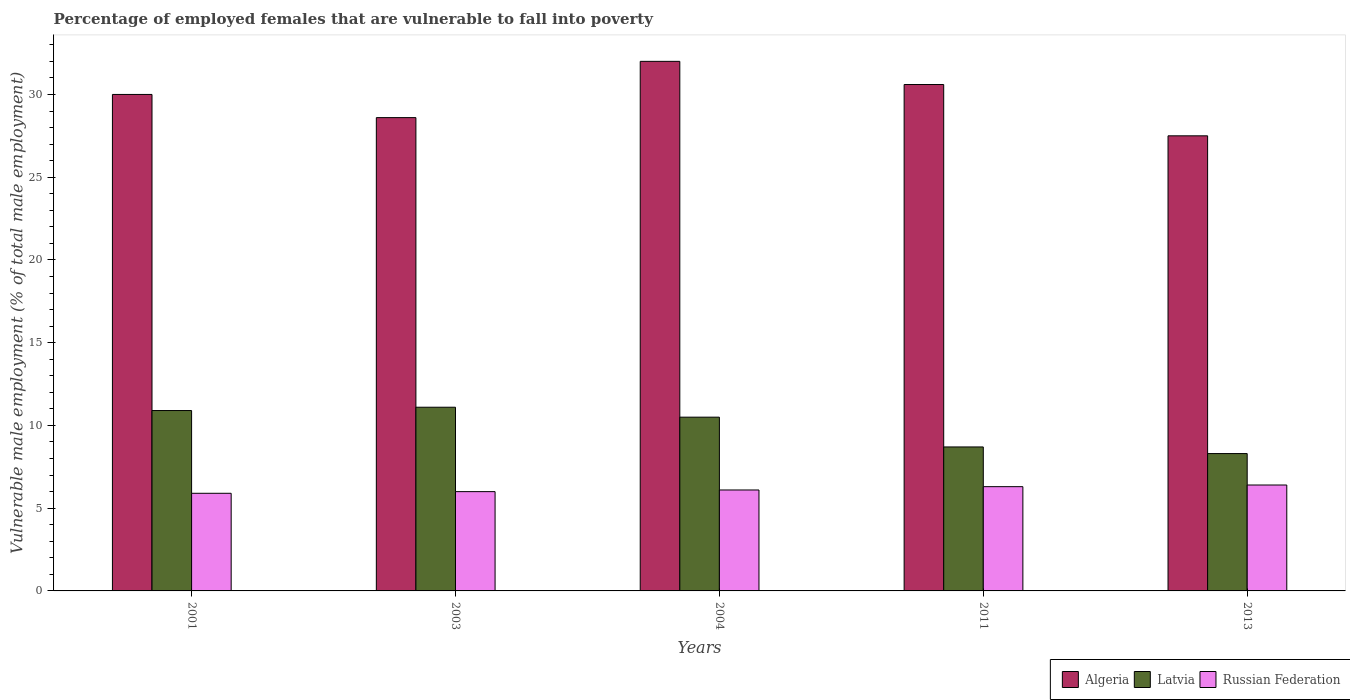How many different coloured bars are there?
Ensure brevity in your answer.  3. How many groups of bars are there?
Your answer should be compact. 5. Are the number of bars on each tick of the X-axis equal?
Ensure brevity in your answer.  Yes. How many bars are there on the 5th tick from the right?
Ensure brevity in your answer.  3. What is the label of the 5th group of bars from the left?
Your response must be concise. 2013. In how many cases, is the number of bars for a given year not equal to the number of legend labels?
Your answer should be very brief. 0. What is the percentage of employed females who are vulnerable to fall into poverty in Latvia in 2013?
Offer a terse response. 8.3. Across all years, what is the maximum percentage of employed females who are vulnerable to fall into poverty in Latvia?
Your answer should be compact. 11.1. Across all years, what is the minimum percentage of employed females who are vulnerable to fall into poverty in Russian Federation?
Provide a succinct answer. 5.9. What is the total percentage of employed females who are vulnerable to fall into poverty in Latvia in the graph?
Your response must be concise. 49.5. What is the difference between the percentage of employed females who are vulnerable to fall into poverty in Latvia in 2001 and that in 2013?
Your response must be concise. 2.6. What is the difference between the percentage of employed females who are vulnerable to fall into poverty in Russian Federation in 2001 and the percentage of employed females who are vulnerable to fall into poverty in Latvia in 2004?
Your answer should be compact. -4.6. What is the average percentage of employed females who are vulnerable to fall into poverty in Algeria per year?
Keep it short and to the point. 29.74. In the year 2003, what is the difference between the percentage of employed females who are vulnerable to fall into poverty in Russian Federation and percentage of employed females who are vulnerable to fall into poverty in Latvia?
Your response must be concise. -5.1. What is the ratio of the percentage of employed females who are vulnerable to fall into poverty in Algeria in 2001 to that in 2004?
Offer a very short reply. 0.94. Is the difference between the percentage of employed females who are vulnerable to fall into poverty in Russian Federation in 2011 and 2013 greater than the difference between the percentage of employed females who are vulnerable to fall into poverty in Latvia in 2011 and 2013?
Make the answer very short. No. What is the difference between the highest and the second highest percentage of employed females who are vulnerable to fall into poverty in Algeria?
Your answer should be compact. 1.4. What does the 1st bar from the left in 2004 represents?
Provide a short and direct response. Algeria. What does the 1st bar from the right in 2004 represents?
Your answer should be very brief. Russian Federation. How many bars are there?
Your answer should be very brief. 15. How many years are there in the graph?
Make the answer very short. 5. What is the difference between two consecutive major ticks on the Y-axis?
Make the answer very short. 5. How many legend labels are there?
Make the answer very short. 3. How are the legend labels stacked?
Keep it short and to the point. Horizontal. What is the title of the graph?
Your answer should be very brief. Percentage of employed females that are vulnerable to fall into poverty. What is the label or title of the Y-axis?
Provide a succinct answer. Vulnerable male employment (% of total male employment). What is the Vulnerable male employment (% of total male employment) of Algeria in 2001?
Make the answer very short. 30. What is the Vulnerable male employment (% of total male employment) of Latvia in 2001?
Give a very brief answer. 10.9. What is the Vulnerable male employment (% of total male employment) of Russian Federation in 2001?
Make the answer very short. 5.9. What is the Vulnerable male employment (% of total male employment) in Algeria in 2003?
Your response must be concise. 28.6. What is the Vulnerable male employment (% of total male employment) of Latvia in 2003?
Your response must be concise. 11.1. What is the Vulnerable male employment (% of total male employment) in Russian Federation in 2003?
Provide a succinct answer. 6. What is the Vulnerable male employment (% of total male employment) in Algeria in 2004?
Provide a short and direct response. 32. What is the Vulnerable male employment (% of total male employment) of Russian Federation in 2004?
Your answer should be compact. 6.1. What is the Vulnerable male employment (% of total male employment) in Algeria in 2011?
Keep it short and to the point. 30.6. What is the Vulnerable male employment (% of total male employment) in Latvia in 2011?
Provide a short and direct response. 8.7. What is the Vulnerable male employment (% of total male employment) of Russian Federation in 2011?
Your response must be concise. 6.3. What is the Vulnerable male employment (% of total male employment) in Algeria in 2013?
Ensure brevity in your answer.  27.5. What is the Vulnerable male employment (% of total male employment) in Latvia in 2013?
Your answer should be compact. 8.3. What is the Vulnerable male employment (% of total male employment) of Russian Federation in 2013?
Provide a succinct answer. 6.4. Across all years, what is the maximum Vulnerable male employment (% of total male employment) in Algeria?
Offer a terse response. 32. Across all years, what is the maximum Vulnerable male employment (% of total male employment) in Latvia?
Provide a succinct answer. 11.1. Across all years, what is the maximum Vulnerable male employment (% of total male employment) of Russian Federation?
Offer a very short reply. 6.4. Across all years, what is the minimum Vulnerable male employment (% of total male employment) of Algeria?
Your response must be concise. 27.5. Across all years, what is the minimum Vulnerable male employment (% of total male employment) of Latvia?
Give a very brief answer. 8.3. Across all years, what is the minimum Vulnerable male employment (% of total male employment) in Russian Federation?
Your answer should be very brief. 5.9. What is the total Vulnerable male employment (% of total male employment) of Algeria in the graph?
Your response must be concise. 148.7. What is the total Vulnerable male employment (% of total male employment) in Latvia in the graph?
Offer a very short reply. 49.5. What is the total Vulnerable male employment (% of total male employment) in Russian Federation in the graph?
Provide a succinct answer. 30.7. What is the difference between the Vulnerable male employment (% of total male employment) of Russian Federation in 2001 and that in 2003?
Your answer should be very brief. -0.1. What is the difference between the Vulnerable male employment (% of total male employment) of Algeria in 2001 and that in 2011?
Your response must be concise. -0.6. What is the difference between the Vulnerable male employment (% of total male employment) of Russian Federation in 2001 and that in 2011?
Offer a very short reply. -0.4. What is the difference between the Vulnerable male employment (% of total male employment) of Algeria in 2001 and that in 2013?
Offer a terse response. 2.5. What is the difference between the Vulnerable male employment (% of total male employment) of Latvia in 2001 and that in 2013?
Offer a terse response. 2.6. What is the difference between the Vulnerable male employment (% of total male employment) in Algeria in 2003 and that in 2011?
Provide a short and direct response. -2. What is the difference between the Vulnerable male employment (% of total male employment) of Latvia in 2003 and that in 2011?
Provide a succinct answer. 2.4. What is the difference between the Vulnerable male employment (% of total male employment) of Russian Federation in 2003 and that in 2011?
Provide a short and direct response. -0.3. What is the difference between the Vulnerable male employment (% of total male employment) of Russian Federation in 2003 and that in 2013?
Keep it short and to the point. -0.4. What is the difference between the Vulnerable male employment (% of total male employment) in Algeria in 2004 and that in 2011?
Your response must be concise. 1.4. What is the difference between the Vulnerable male employment (% of total male employment) in Latvia in 2004 and that in 2011?
Your answer should be very brief. 1.8. What is the difference between the Vulnerable male employment (% of total male employment) of Russian Federation in 2004 and that in 2011?
Give a very brief answer. -0.2. What is the difference between the Vulnerable male employment (% of total male employment) in Latvia in 2004 and that in 2013?
Ensure brevity in your answer.  2.2. What is the difference between the Vulnerable male employment (% of total male employment) of Algeria in 2011 and that in 2013?
Offer a very short reply. 3.1. What is the difference between the Vulnerable male employment (% of total male employment) in Latvia in 2011 and that in 2013?
Offer a very short reply. 0.4. What is the difference between the Vulnerable male employment (% of total male employment) of Russian Federation in 2011 and that in 2013?
Ensure brevity in your answer.  -0.1. What is the difference between the Vulnerable male employment (% of total male employment) in Algeria in 2001 and the Vulnerable male employment (% of total male employment) in Russian Federation in 2003?
Keep it short and to the point. 24. What is the difference between the Vulnerable male employment (% of total male employment) of Algeria in 2001 and the Vulnerable male employment (% of total male employment) of Russian Federation in 2004?
Offer a very short reply. 23.9. What is the difference between the Vulnerable male employment (% of total male employment) in Latvia in 2001 and the Vulnerable male employment (% of total male employment) in Russian Federation in 2004?
Your answer should be very brief. 4.8. What is the difference between the Vulnerable male employment (% of total male employment) in Algeria in 2001 and the Vulnerable male employment (% of total male employment) in Latvia in 2011?
Ensure brevity in your answer.  21.3. What is the difference between the Vulnerable male employment (% of total male employment) in Algeria in 2001 and the Vulnerable male employment (% of total male employment) in Russian Federation in 2011?
Make the answer very short. 23.7. What is the difference between the Vulnerable male employment (% of total male employment) of Latvia in 2001 and the Vulnerable male employment (% of total male employment) of Russian Federation in 2011?
Offer a terse response. 4.6. What is the difference between the Vulnerable male employment (% of total male employment) in Algeria in 2001 and the Vulnerable male employment (% of total male employment) in Latvia in 2013?
Offer a terse response. 21.7. What is the difference between the Vulnerable male employment (% of total male employment) in Algeria in 2001 and the Vulnerable male employment (% of total male employment) in Russian Federation in 2013?
Your answer should be compact. 23.6. What is the difference between the Vulnerable male employment (% of total male employment) in Latvia in 2001 and the Vulnerable male employment (% of total male employment) in Russian Federation in 2013?
Ensure brevity in your answer.  4.5. What is the difference between the Vulnerable male employment (% of total male employment) of Algeria in 2003 and the Vulnerable male employment (% of total male employment) of Latvia in 2004?
Keep it short and to the point. 18.1. What is the difference between the Vulnerable male employment (% of total male employment) in Latvia in 2003 and the Vulnerable male employment (% of total male employment) in Russian Federation in 2004?
Ensure brevity in your answer.  5. What is the difference between the Vulnerable male employment (% of total male employment) in Algeria in 2003 and the Vulnerable male employment (% of total male employment) in Russian Federation in 2011?
Ensure brevity in your answer.  22.3. What is the difference between the Vulnerable male employment (% of total male employment) of Latvia in 2003 and the Vulnerable male employment (% of total male employment) of Russian Federation in 2011?
Provide a short and direct response. 4.8. What is the difference between the Vulnerable male employment (% of total male employment) in Algeria in 2003 and the Vulnerable male employment (% of total male employment) in Latvia in 2013?
Give a very brief answer. 20.3. What is the difference between the Vulnerable male employment (% of total male employment) of Latvia in 2003 and the Vulnerable male employment (% of total male employment) of Russian Federation in 2013?
Provide a short and direct response. 4.7. What is the difference between the Vulnerable male employment (% of total male employment) in Algeria in 2004 and the Vulnerable male employment (% of total male employment) in Latvia in 2011?
Give a very brief answer. 23.3. What is the difference between the Vulnerable male employment (% of total male employment) of Algeria in 2004 and the Vulnerable male employment (% of total male employment) of Russian Federation in 2011?
Your answer should be compact. 25.7. What is the difference between the Vulnerable male employment (% of total male employment) of Algeria in 2004 and the Vulnerable male employment (% of total male employment) of Latvia in 2013?
Provide a short and direct response. 23.7. What is the difference between the Vulnerable male employment (% of total male employment) in Algeria in 2004 and the Vulnerable male employment (% of total male employment) in Russian Federation in 2013?
Give a very brief answer. 25.6. What is the difference between the Vulnerable male employment (% of total male employment) of Latvia in 2004 and the Vulnerable male employment (% of total male employment) of Russian Federation in 2013?
Offer a very short reply. 4.1. What is the difference between the Vulnerable male employment (% of total male employment) of Algeria in 2011 and the Vulnerable male employment (% of total male employment) of Latvia in 2013?
Offer a terse response. 22.3. What is the difference between the Vulnerable male employment (% of total male employment) in Algeria in 2011 and the Vulnerable male employment (% of total male employment) in Russian Federation in 2013?
Offer a terse response. 24.2. What is the difference between the Vulnerable male employment (% of total male employment) in Latvia in 2011 and the Vulnerable male employment (% of total male employment) in Russian Federation in 2013?
Your answer should be compact. 2.3. What is the average Vulnerable male employment (% of total male employment) in Algeria per year?
Give a very brief answer. 29.74. What is the average Vulnerable male employment (% of total male employment) in Russian Federation per year?
Ensure brevity in your answer.  6.14. In the year 2001, what is the difference between the Vulnerable male employment (% of total male employment) in Algeria and Vulnerable male employment (% of total male employment) in Russian Federation?
Make the answer very short. 24.1. In the year 2001, what is the difference between the Vulnerable male employment (% of total male employment) of Latvia and Vulnerable male employment (% of total male employment) of Russian Federation?
Give a very brief answer. 5. In the year 2003, what is the difference between the Vulnerable male employment (% of total male employment) of Algeria and Vulnerable male employment (% of total male employment) of Russian Federation?
Give a very brief answer. 22.6. In the year 2003, what is the difference between the Vulnerable male employment (% of total male employment) in Latvia and Vulnerable male employment (% of total male employment) in Russian Federation?
Offer a very short reply. 5.1. In the year 2004, what is the difference between the Vulnerable male employment (% of total male employment) of Algeria and Vulnerable male employment (% of total male employment) of Latvia?
Your response must be concise. 21.5. In the year 2004, what is the difference between the Vulnerable male employment (% of total male employment) of Algeria and Vulnerable male employment (% of total male employment) of Russian Federation?
Offer a terse response. 25.9. In the year 2004, what is the difference between the Vulnerable male employment (% of total male employment) of Latvia and Vulnerable male employment (% of total male employment) of Russian Federation?
Give a very brief answer. 4.4. In the year 2011, what is the difference between the Vulnerable male employment (% of total male employment) of Algeria and Vulnerable male employment (% of total male employment) of Latvia?
Offer a terse response. 21.9. In the year 2011, what is the difference between the Vulnerable male employment (% of total male employment) in Algeria and Vulnerable male employment (% of total male employment) in Russian Federation?
Your response must be concise. 24.3. In the year 2011, what is the difference between the Vulnerable male employment (% of total male employment) of Latvia and Vulnerable male employment (% of total male employment) of Russian Federation?
Your answer should be very brief. 2.4. In the year 2013, what is the difference between the Vulnerable male employment (% of total male employment) of Algeria and Vulnerable male employment (% of total male employment) of Russian Federation?
Keep it short and to the point. 21.1. What is the ratio of the Vulnerable male employment (% of total male employment) of Algeria in 2001 to that in 2003?
Provide a short and direct response. 1.05. What is the ratio of the Vulnerable male employment (% of total male employment) in Latvia in 2001 to that in 2003?
Offer a terse response. 0.98. What is the ratio of the Vulnerable male employment (% of total male employment) in Russian Federation in 2001 to that in 2003?
Your answer should be very brief. 0.98. What is the ratio of the Vulnerable male employment (% of total male employment) of Algeria in 2001 to that in 2004?
Make the answer very short. 0.94. What is the ratio of the Vulnerable male employment (% of total male employment) of Latvia in 2001 to that in 2004?
Your answer should be compact. 1.04. What is the ratio of the Vulnerable male employment (% of total male employment) of Russian Federation in 2001 to that in 2004?
Your answer should be very brief. 0.97. What is the ratio of the Vulnerable male employment (% of total male employment) of Algeria in 2001 to that in 2011?
Your response must be concise. 0.98. What is the ratio of the Vulnerable male employment (% of total male employment) of Latvia in 2001 to that in 2011?
Offer a terse response. 1.25. What is the ratio of the Vulnerable male employment (% of total male employment) in Russian Federation in 2001 to that in 2011?
Offer a terse response. 0.94. What is the ratio of the Vulnerable male employment (% of total male employment) in Algeria in 2001 to that in 2013?
Provide a short and direct response. 1.09. What is the ratio of the Vulnerable male employment (% of total male employment) in Latvia in 2001 to that in 2013?
Ensure brevity in your answer.  1.31. What is the ratio of the Vulnerable male employment (% of total male employment) of Russian Federation in 2001 to that in 2013?
Provide a short and direct response. 0.92. What is the ratio of the Vulnerable male employment (% of total male employment) in Algeria in 2003 to that in 2004?
Your response must be concise. 0.89. What is the ratio of the Vulnerable male employment (% of total male employment) in Latvia in 2003 to that in 2004?
Offer a terse response. 1.06. What is the ratio of the Vulnerable male employment (% of total male employment) of Russian Federation in 2003 to that in 2004?
Provide a succinct answer. 0.98. What is the ratio of the Vulnerable male employment (% of total male employment) in Algeria in 2003 to that in 2011?
Give a very brief answer. 0.93. What is the ratio of the Vulnerable male employment (% of total male employment) of Latvia in 2003 to that in 2011?
Your answer should be compact. 1.28. What is the ratio of the Vulnerable male employment (% of total male employment) of Latvia in 2003 to that in 2013?
Give a very brief answer. 1.34. What is the ratio of the Vulnerable male employment (% of total male employment) of Russian Federation in 2003 to that in 2013?
Make the answer very short. 0.94. What is the ratio of the Vulnerable male employment (% of total male employment) of Algeria in 2004 to that in 2011?
Keep it short and to the point. 1.05. What is the ratio of the Vulnerable male employment (% of total male employment) of Latvia in 2004 to that in 2011?
Give a very brief answer. 1.21. What is the ratio of the Vulnerable male employment (% of total male employment) in Russian Federation in 2004 to that in 2011?
Keep it short and to the point. 0.97. What is the ratio of the Vulnerable male employment (% of total male employment) in Algeria in 2004 to that in 2013?
Provide a short and direct response. 1.16. What is the ratio of the Vulnerable male employment (% of total male employment) in Latvia in 2004 to that in 2013?
Offer a terse response. 1.27. What is the ratio of the Vulnerable male employment (% of total male employment) of Russian Federation in 2004 to that in 2013?
Offer a very short reply. 0.95. What is the ratio of the Vulnerable male employment (% of total male employment) in Algeria in 2011 to that in 2013?
Provide a succinct answer. 1.11. What is the ratio of the Vulnerable male employment (% of total male employment) of Latvia in 2011 to that in 2013?
Your response must be concise. 1.05. What is the ratio of the Vulnerable male employment (% of total male employment) of Russian Federation in 2011 to that in 2013?
Provide a succinct answer. 0.98. What is the difference between the highest and the second highest Vulnerable male employment (% of total male employment) of Latvia?
Offer a very short reply. 0.2. What is the difference between the highest and the second highest Vulnerable male employment (% of total male employment) in Russian Federation?
Your answer should be very brief. 0.1. What is the difference between the highest and the lowest Vulnerable male employment (% of total male employment) in Russian Federation?
Offer a very short reply. 0.5. 